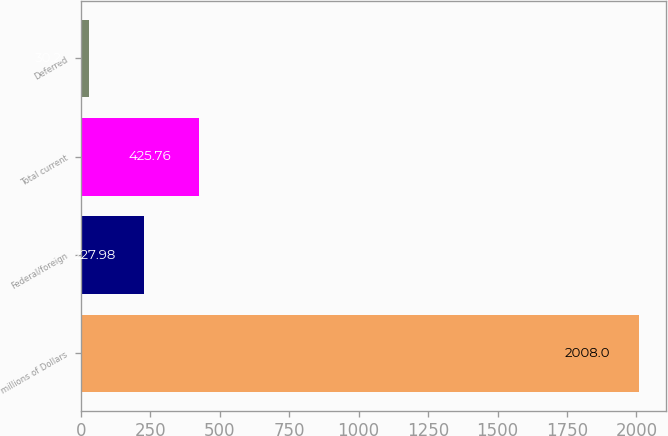Convert chart to OTSL. <chart><loc_0><loc_0><loc_500><loc_500><bar_chart><fcel>millions of Dollars<fcel>Federal/foreign<fcel>Total current<fcel>Deferred<nl><fcel>2008<fcel>227.98<fcel>425.76<fcel>30.2<nl></chart> 